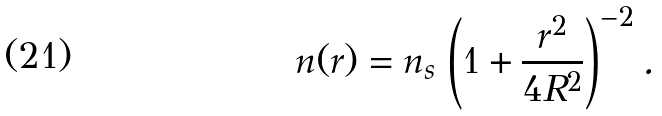Convert formula to latex. <formula><loc_0><loc_0><loc_500><loc_500>n ( { r } ) = n _ { s } \, \left ( 1 + \frac { r ^ { 2 } } { 4 R ^ { 2 } } \right ) ^ { - 2 } .</formula> 